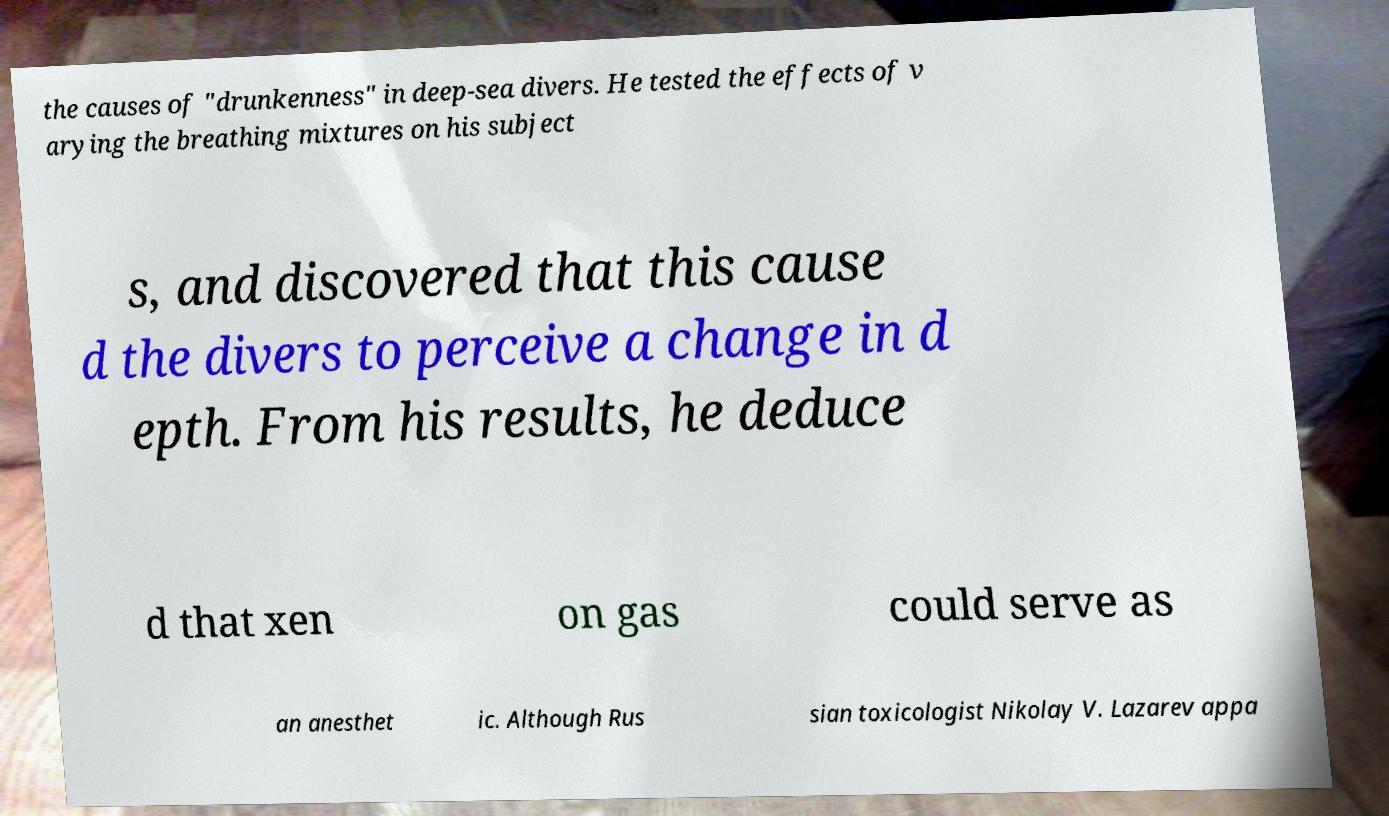Please read and relay the text visible in this image. What does it say? the causes of "drunkenness" in deep-sea divers. He tested the effects of v arying the breathing mixtures on his subject s, and discovered that this cause d the divers to perceive a change in d epth. From his results, he deduce d that xen on gas could serve as an anesthet ic. Although Rus sian toxicologist Nikolay V. Lazarev appa 